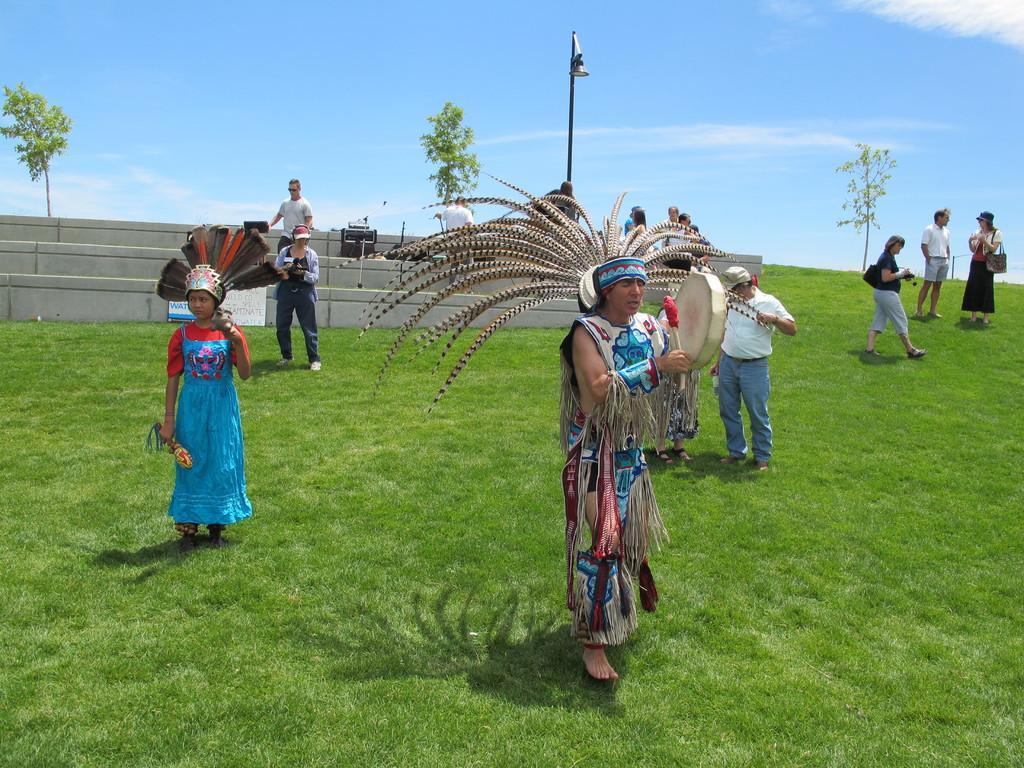Please provide a concise description of this image. In this image we can see persons standing on the ground and some of them are holding musical instruments in their hands. In the background we can see sky with clouds, trees, street pole, street light and staircase. 